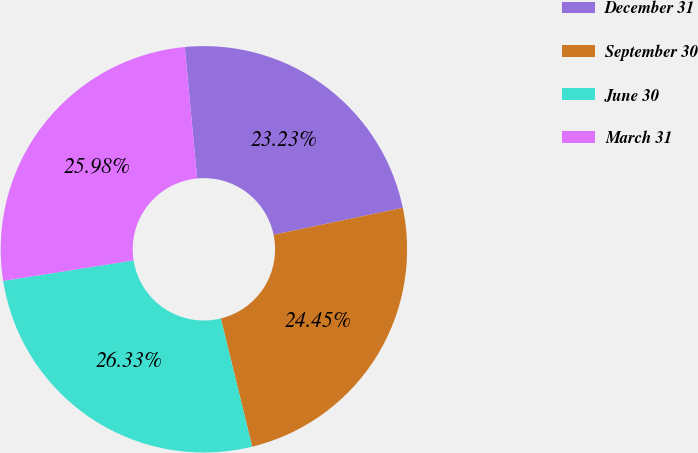<chart> <loc_0><loc_0><loc_500><loc_500><pie_chart><fcel>December 31<fcel>September 30<fcel>June 30<fcel>March 31<nl><fcel>23.23%<fcel>24.45%<fcel>26.33%<fcel>25.98%<nl></chart> 